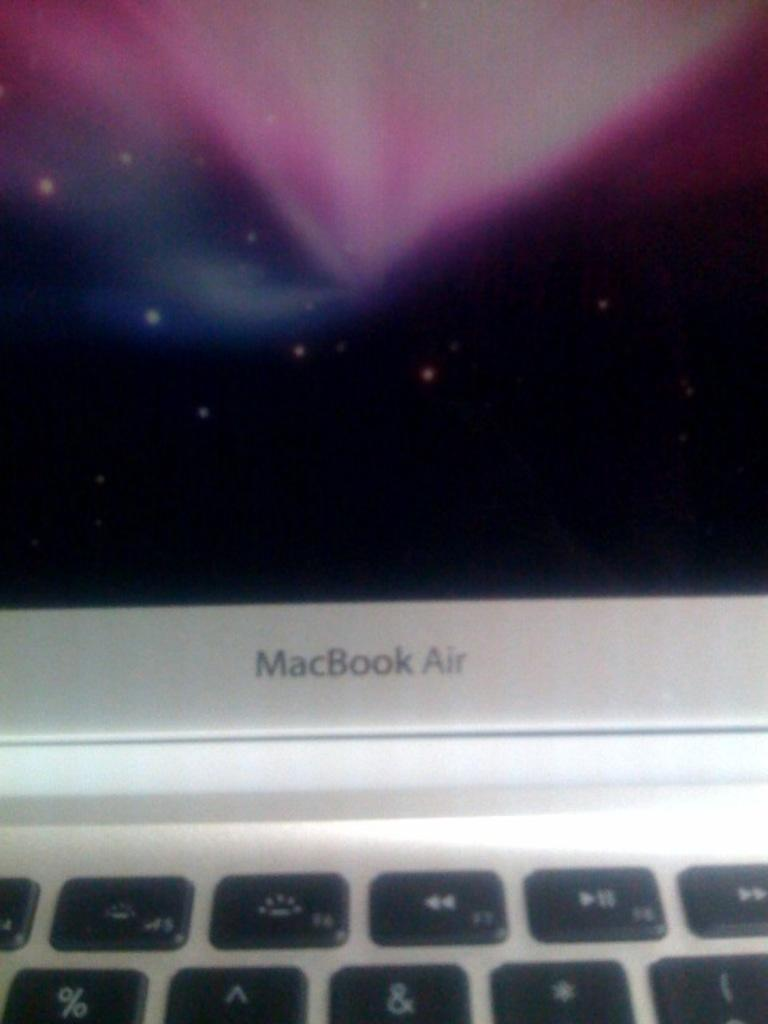<image>
Describe the image concisely. Bottom part of a gray MacBook Air monitor 